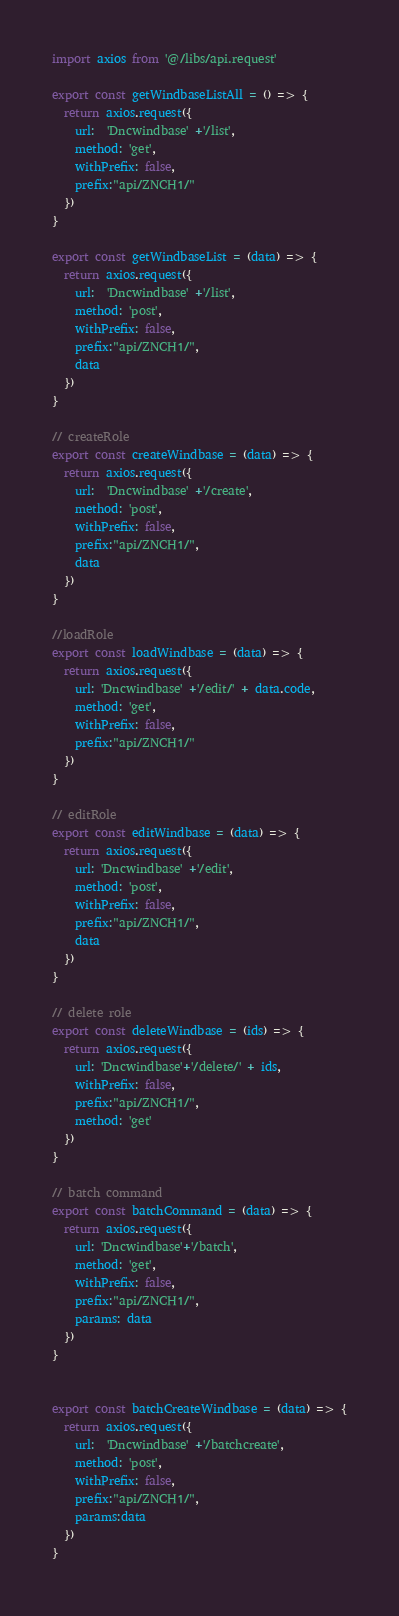<code> <loc_0><loc_0><loc_500><loc_500><_JavaScript_>

import axios from '@/libs/api.request'

export const getWindbaseListAll = () => {
  return axios.request({
    url:  'Dncwindbase' +'/list',
    method: 'get',
    withPrefix: false,
    prefix:"api/ZNCH1/"
  })
}

export const getWindbaseList = (data) => {
  return axios.request({
    url:  'Dncwindbase' +'/list',
    method: 'post',
    withPrefix: false,
    prefix:"api/ZNCH1/",
    data
  })
}

// createRole
export const createWindbase = (data) => {
  return axios.request({
    url:  'Dncwindbase' +'/create',
    method: 'post',
    withPrefix: false,
    prefix:"api/ZNCH1/",
    data
  })
}

//loadRole
export const loadWindbase = (data) => {
  return axios.request({
    url: 'Dncwindbase' +'/edit/' + data.code,
    method: 'get',
    withPrefix: false,
    prefix:"api/ZNCH1/"
  })
}

// editRole
export const editWindbase = (data) => {
  return axios.request({
    url: 'Dncwindbase' +'/edit',
    method: 'post',
    withPrefix: false,
    prefix:"api/ZNCH1/",
    data
  })
}

// delete role
export const deleteWindbase = (ids) => {
  return axios.request({
    url: 'Dncwindbase'+'/delete/' + ids,
    withPrefix: false,
    prefix:"api/ZNCH1/",
    method: 'get'
  })
}

// batch command
export const batchCommand = (data) => {
  return axios.request({
    url: 'Dncwindbase'+'/batch',
    method: 'get',
    withPrefix: false,
    prefix:"api/ZNCH1/",
    params: data
  })
}


export const batchCreateWindbase = (data) => {
  return axios.request({
    url:  'Dncwindbase' +'/batchcreate',
    method: 'post',
    withPrefix: false,
    prefix:"api/ZNCH1/",
    params:data
  })
}

</code> 